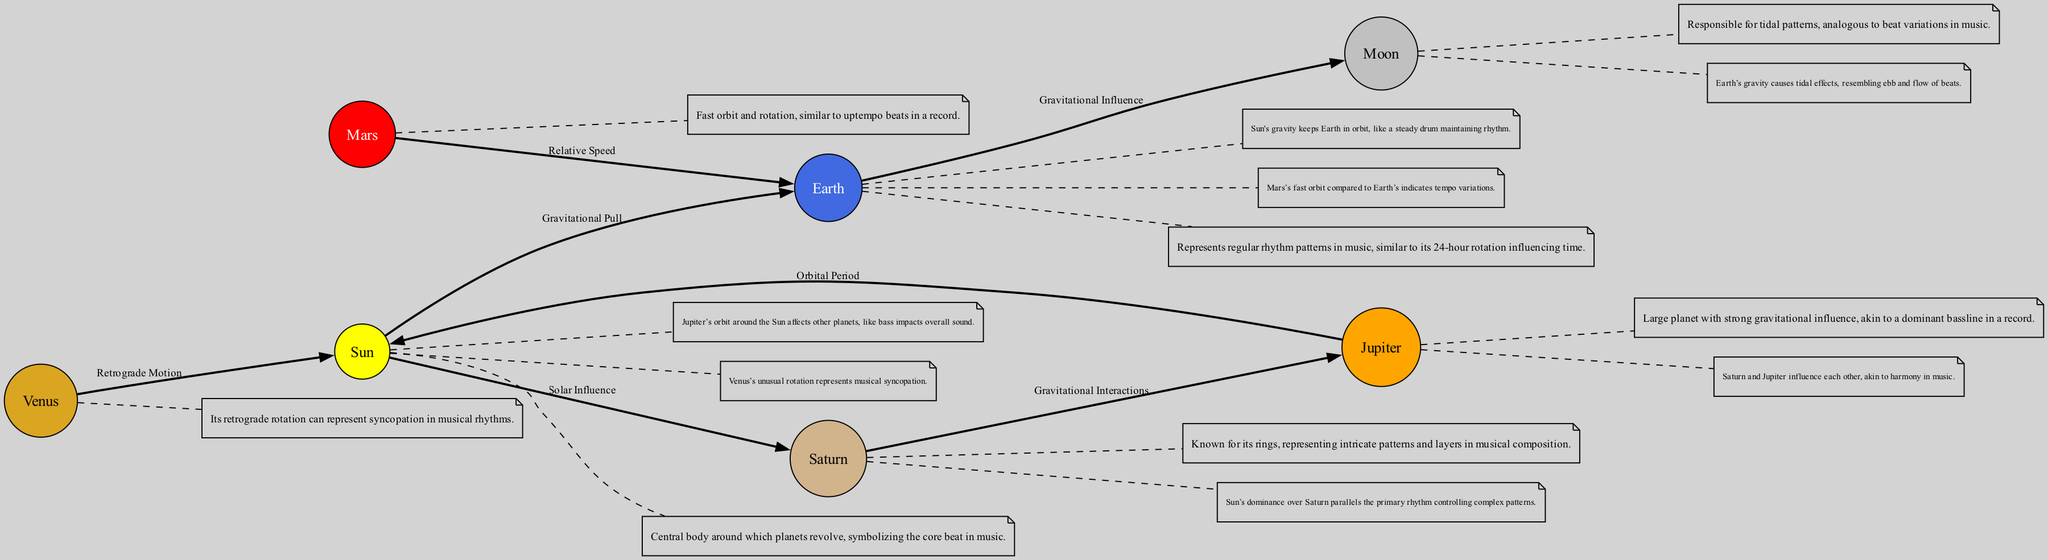What is the central body depicted in the diagram? The diagram clearly labels the node as "Sun," representing the central figure around which other celestial bodies revolve.
Answer: Sun How many planets are represented in this diagram? The diagram shows a total of six planets, which are Earth, Moon, Jupiter, Venus, Mars, and Saturn, in addition to the Sun.
Answer: 6 What gravitational influence is depicted between Earth and Moon? The relationship labeled as "Gravitational Influence" indicates that Earth's gravity causes tidal effects, which are analogous to variations in musical beats.
Answer: Gravitational Influence Which planet is known for its strong gravitational influence? The diagram identifies Jupiter as a planet with a robust gravitational effect, likening this force to a dominant bassline in music.
Answer: Jupiter What does Venus's retrograde motion represent in musical terms? The label on the edge indicates that Venus's unusual rotation can be interpreted as a representation of syncopation within musical rhythms.
Answer: Syncopation How are Saturn and Jupiter connected in the diagram? The edges show "Gravitational Interactions," indicating that Saturn and Jupiter influence each other's orbits, promoting harmony in a musical context.
Answer: Gravitational Interactions What does the Sun's description convey about its role in music? The Sun is described as having a "dominance" over Saturn, symbolically reflecting the primary rhythm in music that controls more complex patterns.
Answer: Dominance Which planet's fast orbit is compared to uptempo beats? Mars is the planet described as having a fast orbit, which echoes the idea of uptempo beats often found in vinyl records.
Answer: Mars What does the description of Saturn refer to in music? The description of Saturn highlights its rings, which symbolize intricate patterns and layers that can be observed in musical compositions.
Answer: Intricate patterns 